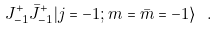Convert formula to latex. <formula><loc_0><loc_0><loc_500><loc_500>J _ { - 1 } ^ { + } \bar { J } _ { - 1 } ^ { + } | j = - 1 ; m = \bar { m } = - 1 \rangle \ .</formula> 